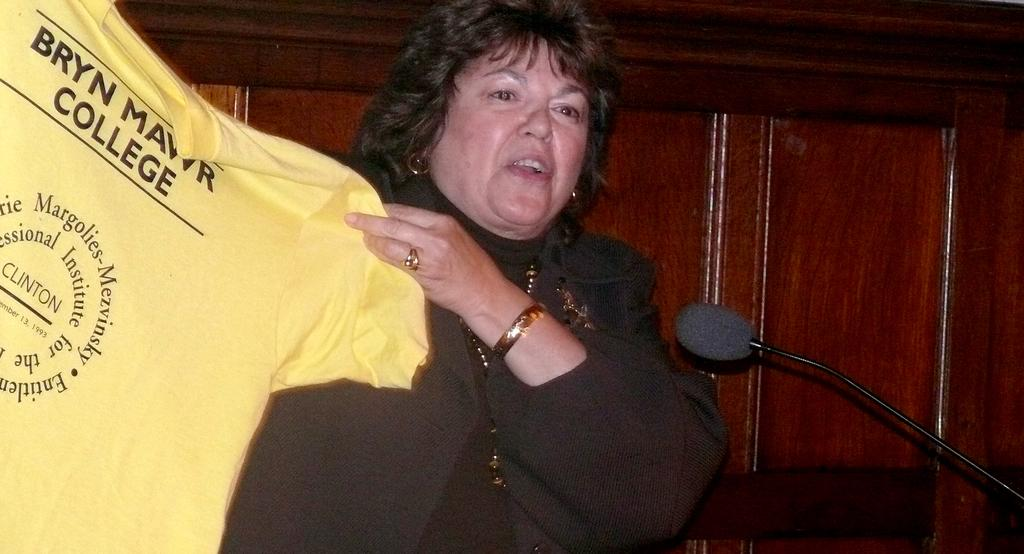Who is the main subject in the image? There is a woman in the image. What is the woman holding in the image? The woman is holding a yellow t-shirt. What object is in front of the woman? There is a microphone in front of the woman. What type of wall can be seen in the background of the image? There is a wooden wall in the background of the image. What type of lead is the woman using to hold the yellow t-shirt? The woman is not using any lead to hold the yellow t-shirt; she is simply holding it with her hands. 